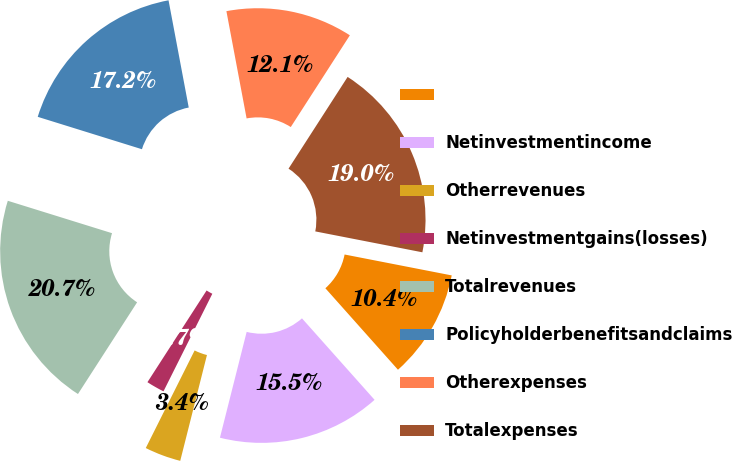<chart> <loc_0><loc_0><loc_500><loc_500><pie_chart><ecel><fcel>Netinvestmentincome<fcel>Otherrevenues<fcel>Netinvestmentgains(losses)<fcel>Totalrevenues<fcel>Policyholderbenefitsandclaims<fcel>Otherexpenses<fcel>Totalexpenses<nl><fcel>10.35%<fcel>15.52%<fcel>3.45%<fcel>1.73%<fcel>20.68%<fcel>17.24%<fcel>12.07%<fcel>18.96%<nl></chart> 